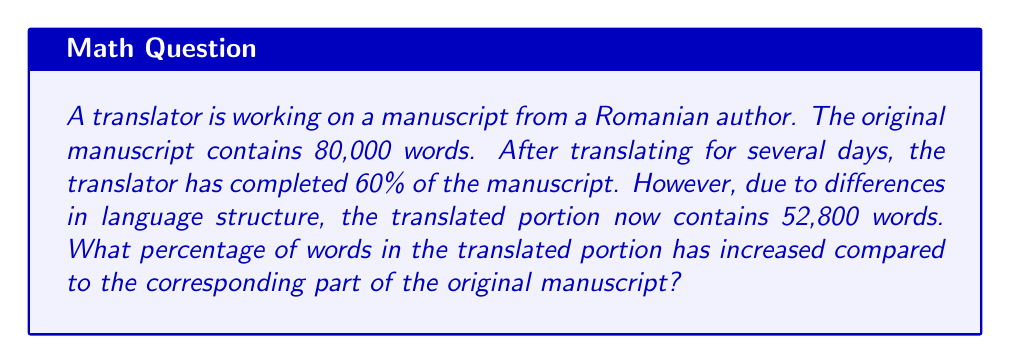Help me with this question. Let's approach this step-by-step:

1. Calculate the number of words in the 60% of the original manuscript that has been translated:
   $$ 80,000 \times 0.60 = 48,000 \text{ words} $$

2. Find the difference between the translated portion and the corresponding original portion:
   $$ 52,800 - 48,000 = 4,800 \text{ words} $$

3. Calculate the percentage increase:
   $$ \text{Percentage increase} = \frac{\text{Increase}}{\text{Original}} \times 100\% $$
   $$ = \frac{4,800}{48,000} \times 100\% $$
   $$ = 0.10 \times 100\% $$
   $$ = 10\% $$

Therefore, the number of words in the translated portion has increased by 10% compared to the corresponding part of the original manuscript.
Answer: 10% 